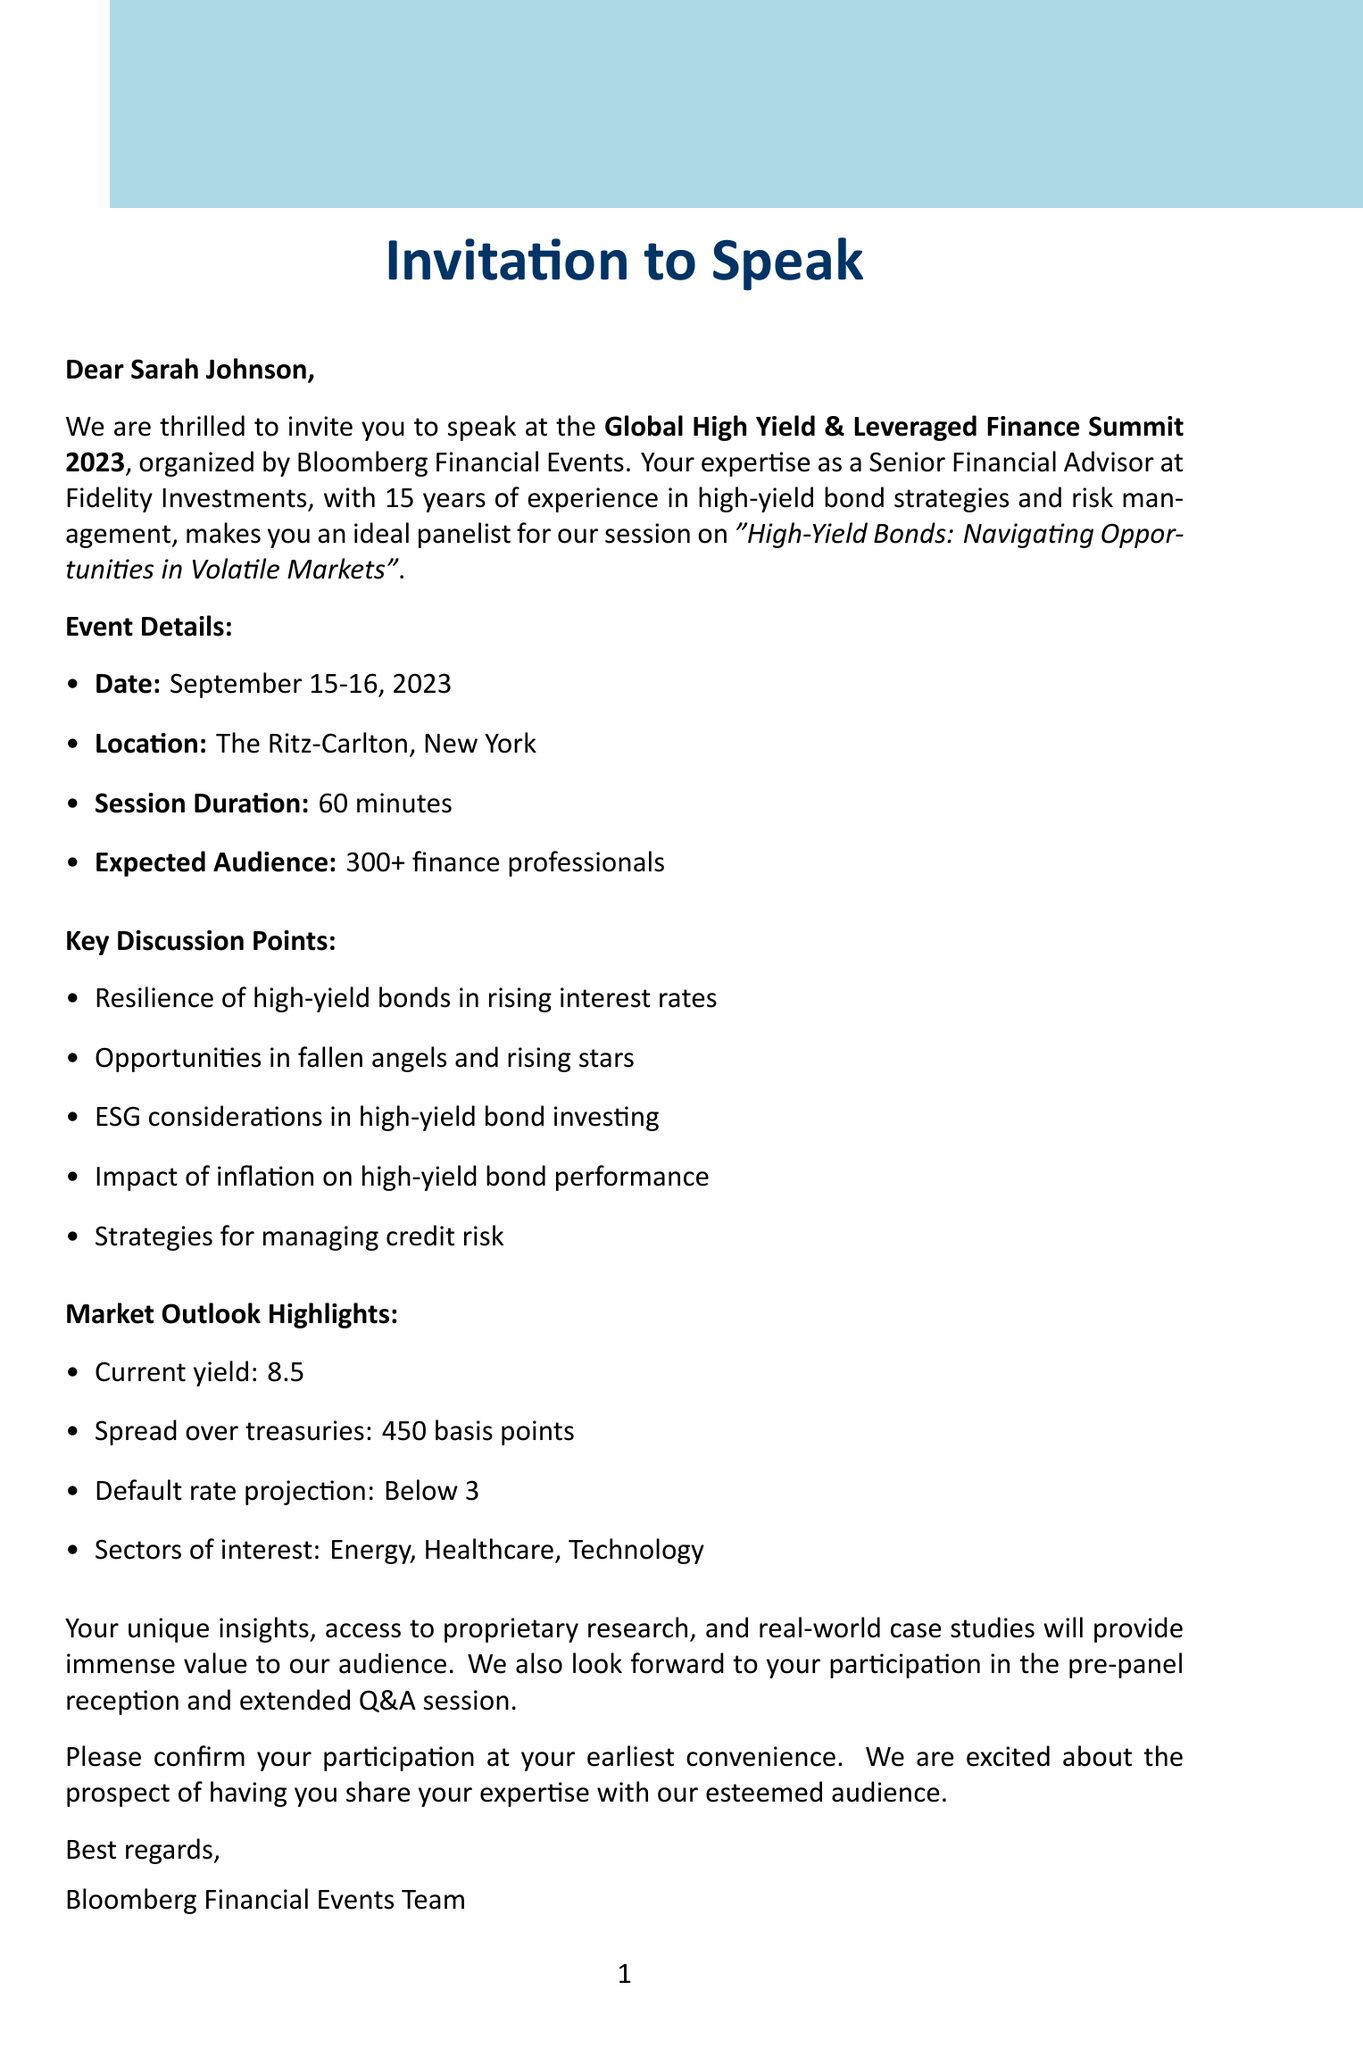What is the name of the conference? The name of the conference is mentioned in the event details section of the document.
Answer: Global High Yield & Leveraged Finance Summit 2023 What are the dates of the conference? The dates of the conference are specified in the event details section.
Answer: September 15-16, 2023 Where is the conference being held? The location of the conference is stated in the event details section of the document.
Answer: The Ritz-Carlton, New York How many finance professionals are expected in the audience? The expected audience size is found in the invitation context.
Answer: 300+ What is the average yield of US high-yield bonds as of August 2023? The average yield is provided in the market outlook highlights.
Answer: 8.5% What are the sectors of interest mentioned? The sectors of interest are listed in the market outlook highlights.
Answer: Energy, Healthcare, Technology Who is the speaker for the panel? The speaker's name is included in the speaker credentials.
Answer: Sarah Johnson What is the primary focus of the panel discussion? The primary focus of the panel discussion is mentioned in the invitation context.
Answer: High-Yield Bonds: Navigating Opportunities in Volatile Markets What opportunities are highlighted in the key discussion points? Opportunities in the key discussion points refer to specific market conditions mentioned in the document.
Answer: Fallen angels and rising stars What is included in the networking opportunities? The networking opportunities section describes various events for attendees.
Answer: Pre-panel reception, post-panel Q&A, conference app 